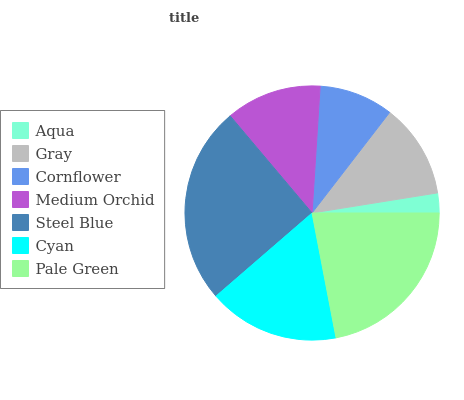Is Aqua the minimum?
Answer yes or no. Yes. Is Steel Blue the maximum?
Answer yes or no. Yes. Is Gray the minimum?
Answer yes or no. No. Is Gray the maximum?
Answer yes or no. No. Is Gray greater than Aqua?
Answer yes or no. Yes. Is Aqua less than Gray?
Answer yes or no. Yes. Is Aqua greater than Gray?
Answer yes or no. No. Is Gray less than Aqua?
Answer yes or no. No. Is Medium Orchid the high median?
Answer yes or no. Yes. Is Medium Orchid the low median?
Answer yes or no. Yes. Is Cornflower the high median?
Answer yes or no. No. Is Steel Blue the low median?
Answer yes or no. No. 